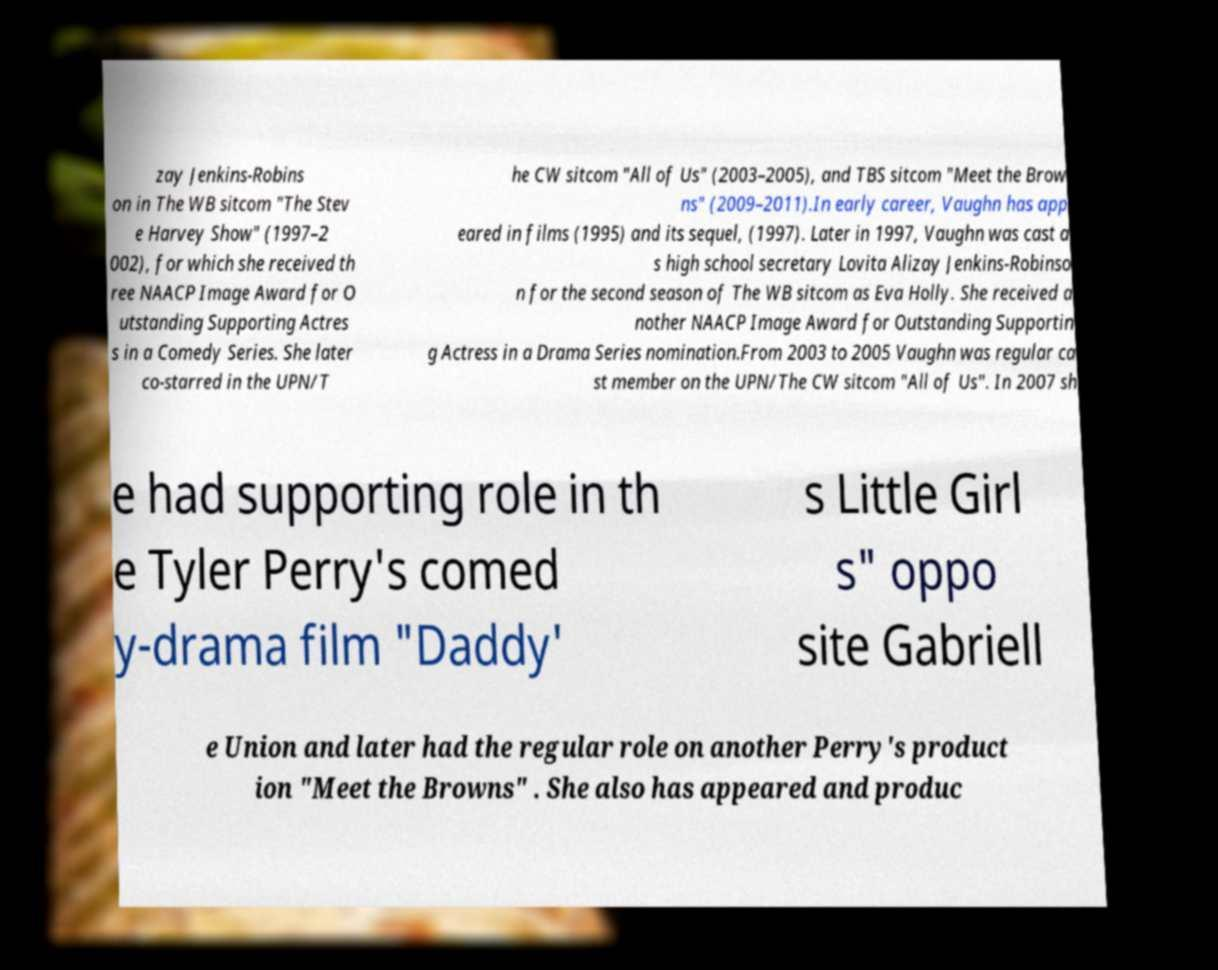Can you read and provide the text displayed in the image?This photo seems to have some interesting text. Can you extract and type it out for me? zay Jenkins-Robins on in The WB sitcom "The Stev e Harvey Show" (1997–2 002), for which she received th ree NAACP Image Award for O utstanding Supporting Actres s in a Comedy Series. She later co-starred in the UPN/T he CW sitcom "All of Us" (2003–2005), and TBS sitcom "Meet the Brow ns" (2009–2011).In early career, Vaughn has app eared in films (1995) and its sequel, (1997). Later in 1997, Vaughn was cast a s high school secretary Lovita Alizay Jenkins-Robinso n for the second season of The WB sitcom as Eva Holly. She received a nother NAACP Image Award for Outstanding Supportin g Actress in a Drama Series nomination.From 2003 to 2005 Vaughn was regular ca st member on the UPN/The CW sitcom "All of Us". In 2007 sh e had supporting role in th e Tyler Perry's comed y-drama film "Daddy' s Little Girl s" oppo site Gabriell e Union and later had the regular role on another Perry's product ion "Meet the Browns" . She also has appeared and produc 